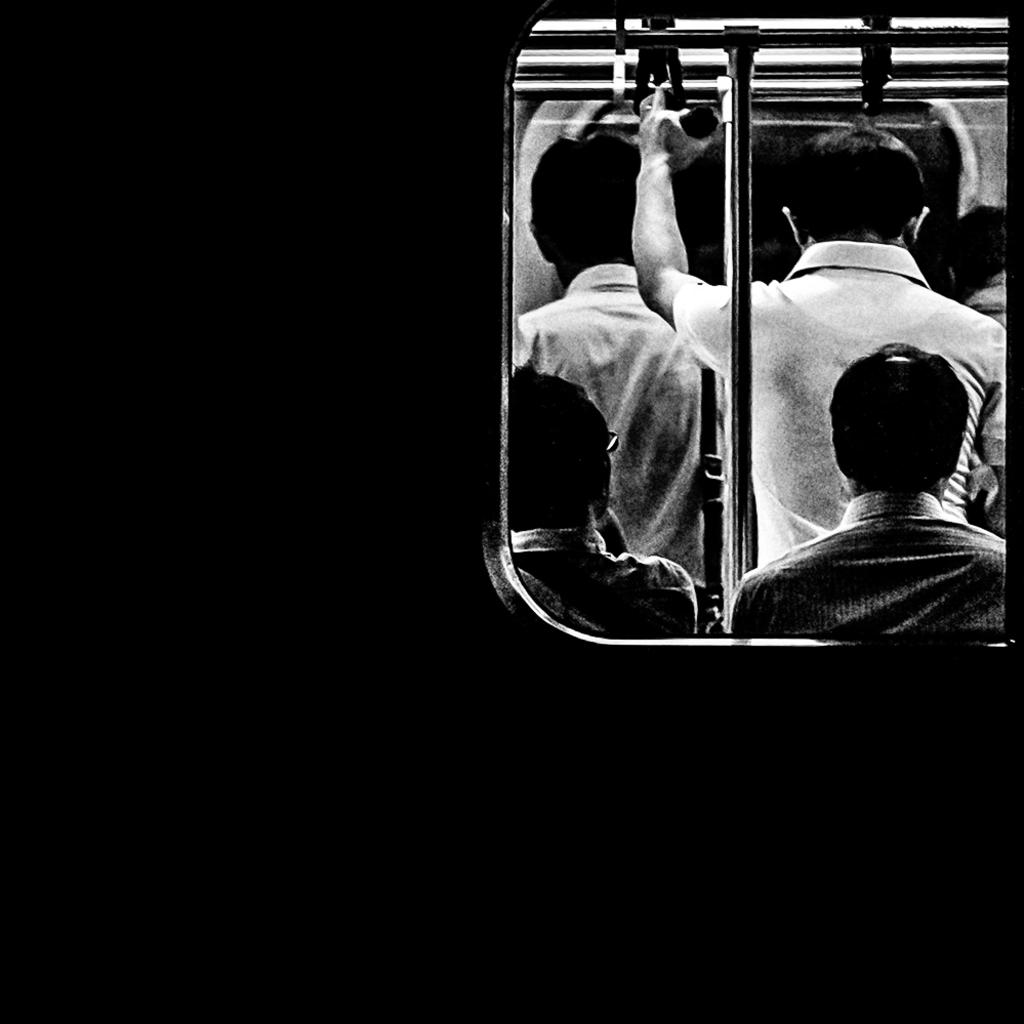What are the people in the image doing? There are persons standing and sitting in the image. Can you describe the man in the center of the image? The man is standing in the center of the image. What is the man holding in the image? The man is holding a rope in the image. Where is the rope located in the image? The rope is on the top in the image. How does the rope burst in the image? The rope does not burst in the image; it is simply held by the man. What type of stretch can be seen in the image? There is no stretch visible in the image; it only shows people standing and sitting and a man holding a rope. 